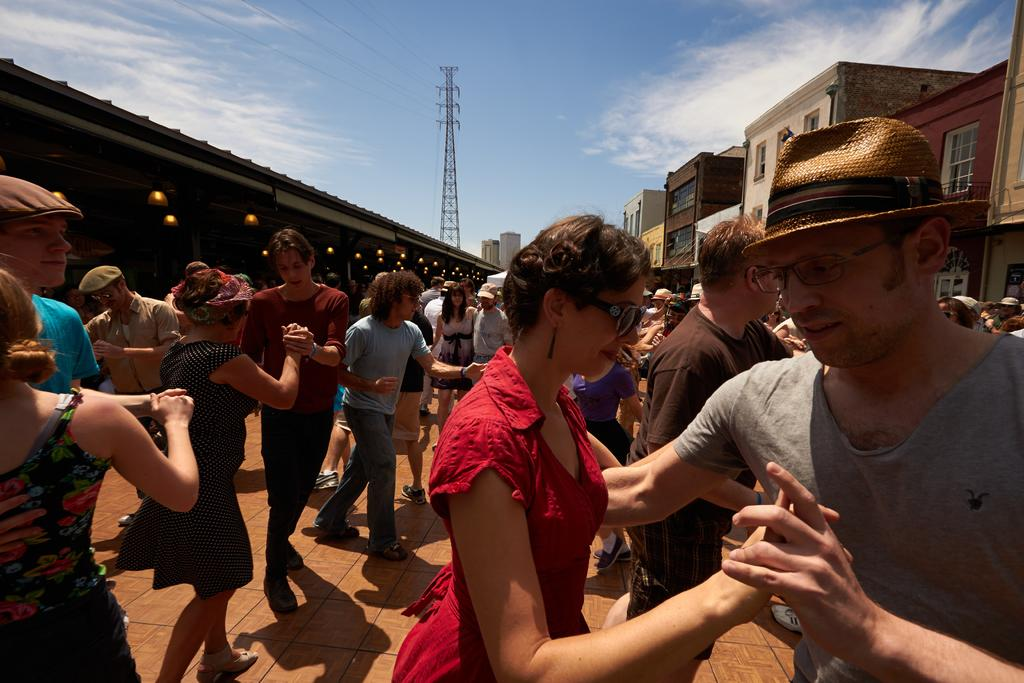What are the people in the image doing? The people in the image are on the floor. Can you describe the gender of the people in the image? There are men and women in the image. What type of structures can be seen in the image? There are buildings and a tower in the image. What is visible in the background of the image? The sky is visible in the background of the image, and there are clouds in the sky. How many spiders are crawling on the tower in the image? There are no spiders visible in the image; the focus is on the people, buildings, and the sky. 